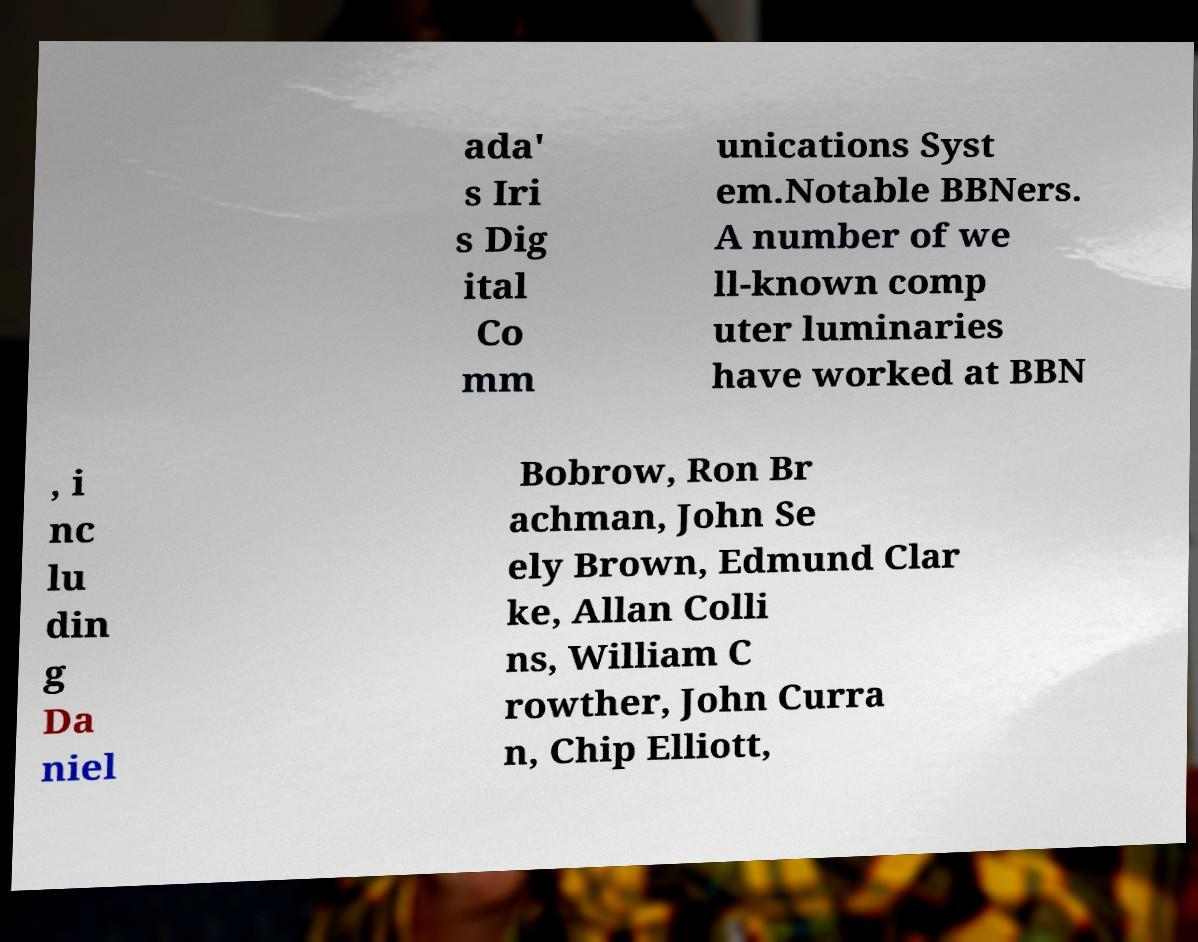I need the written content from this picture converted into text. Can you do that? ada' s Iri s Dig ital Co mm unications Syst em.Notable BBNers. A number of we ll-known comp uter luminaries have worked at BBN , i nc lu din g Da niel Bobrow, Ron Br achman, John Se ely Brown, Edmund Clar ke, Allan Colli ns, William C rowther, John Curra n, Chip Elliott, 